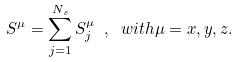<formula> <loc_0><loc_0><loc_500><loc_500>S ^ { \mu } = \sum _ { j = 1 } ^ { N _ { s } } S ^ { \mu } _ { j } \ , \ w i t h \mu = x , y , z .</formula> 